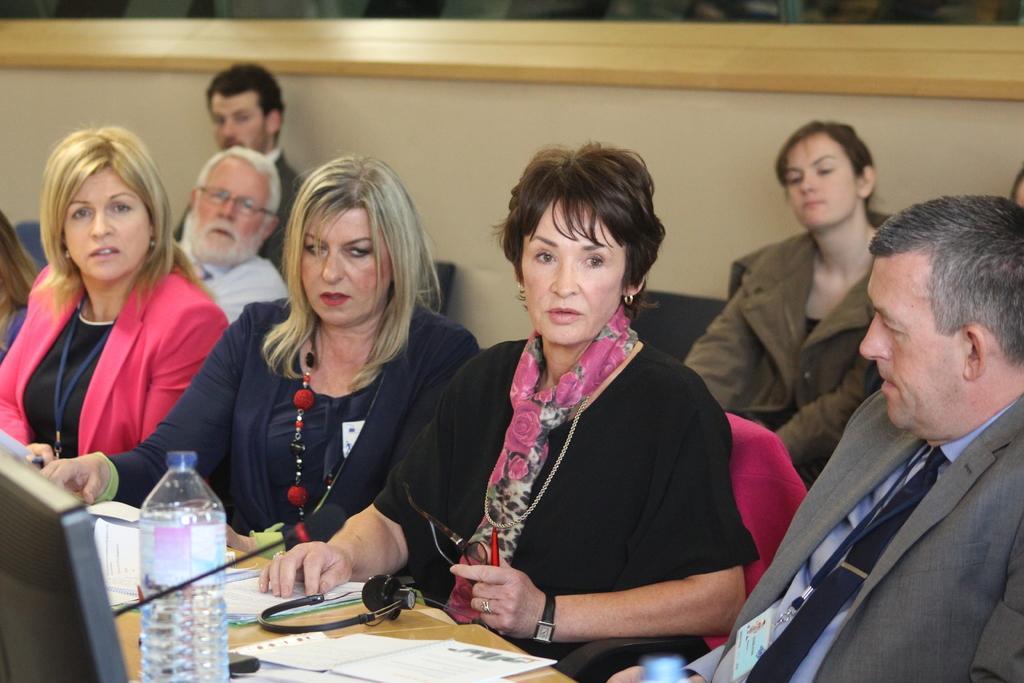In one or two sentences, can you explain what this image depicts? In this image there are few people sitting on chairs. It is looking like a meeting is going on. In the bottom left on a table there is screen, papers, headphone, mic. In the background there is wall. 